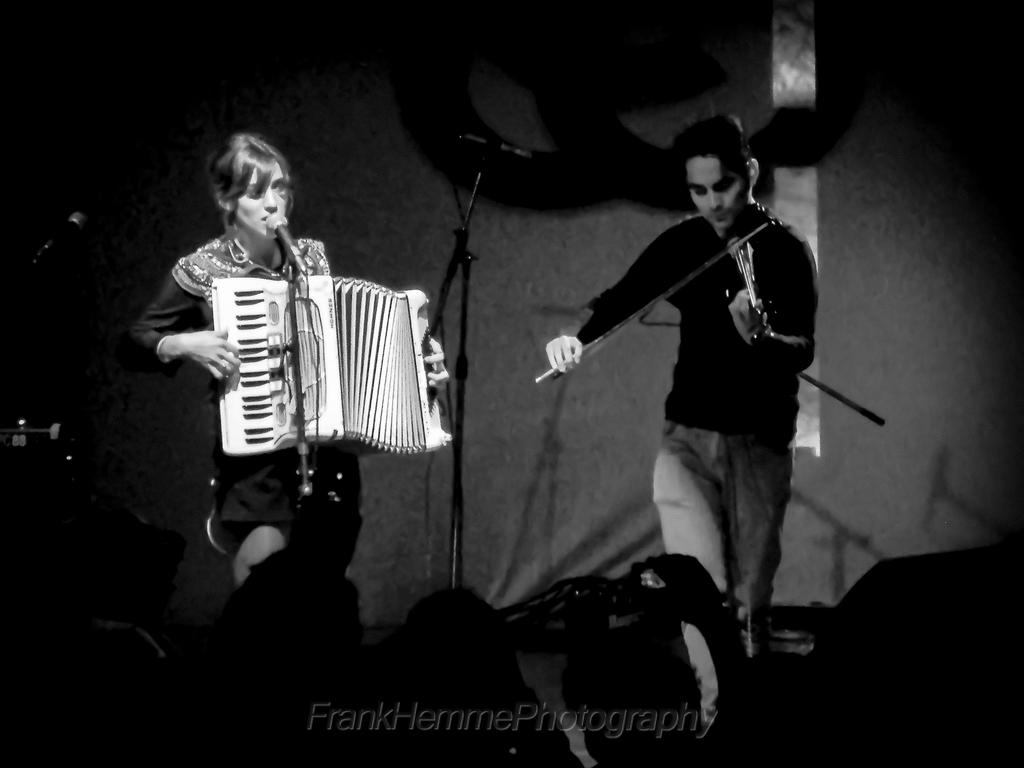What is the woman in the image doing? The woman is playing the piano and singing in the image. What instrument is the other person playing? The other person is playing the violin. What is in front of the woman while she is singing? There is a microphone in front of the woman. Who is present in the image besides the performers? There are audience members in front of the performers. What type of silk is being used by the laborer in the image? There is no laborer or silk present in the image. How many minutes does the performance last in the image? The duration of the performance cannot be determined from the image alone. 